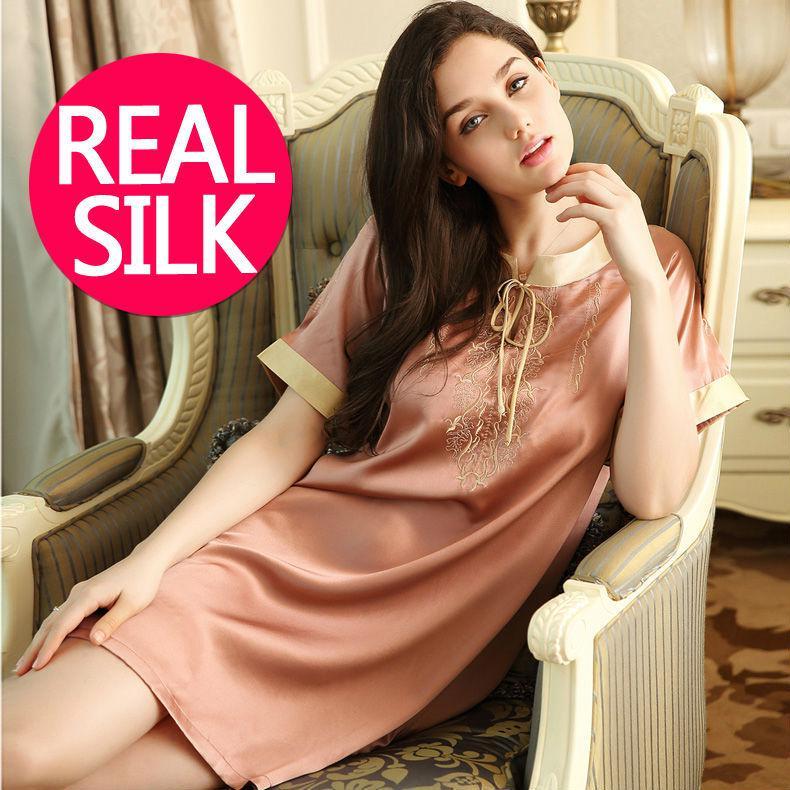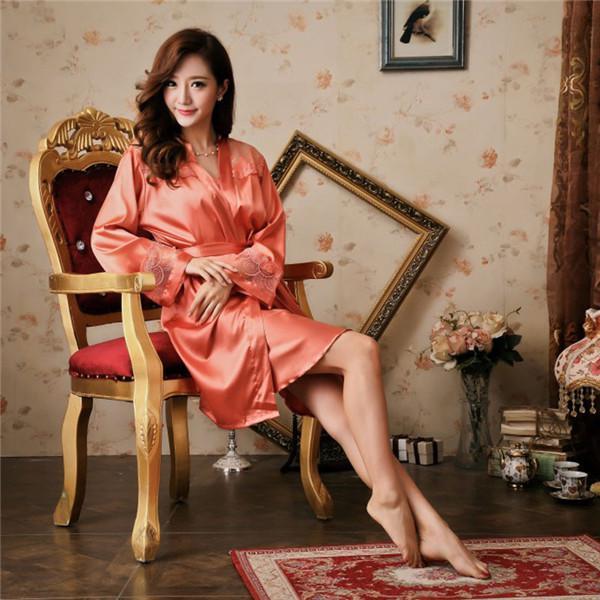The first image is the image on the left, the second image is the image on the right. For the images displayed, is the sentence "An image shows a man to the right of a woman, and both are modeling shiny loungewear." factually correct? Answer yes or no. No. The first image is the image on the left, the second image is the image on the right. Evaluate the accuracy of this statement regarding the images: "A man and woman in pajamas pose near a sofa in one of the images.". Is it true? Answer yes or no. No. 